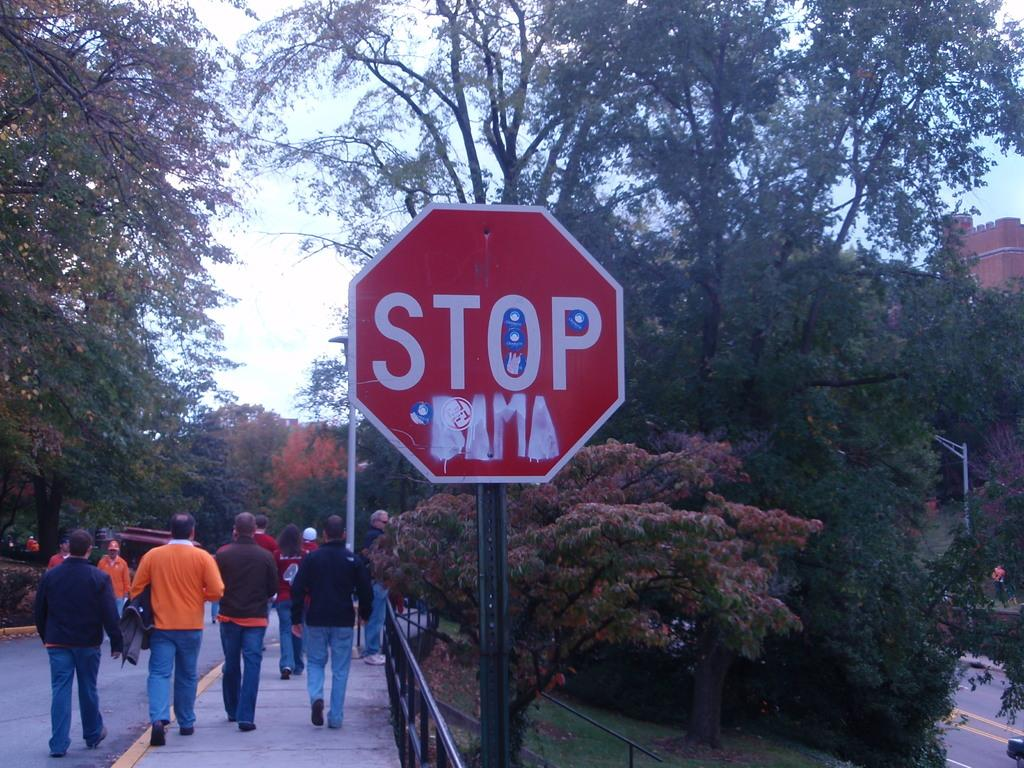<image>
Create a compact narrative representing the image presented. A stop sign, besides which are some people walking. 